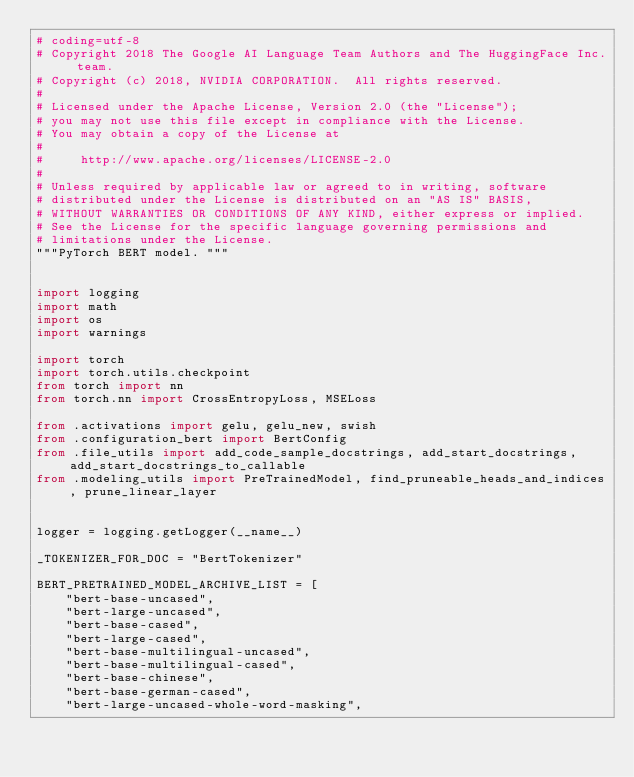<code> <loc_0><loc_0><loc_500><loc_500><_Python_># coding=utf-8
# Copyright 2018 The Google AI Language Team Authors and The HuggingFace Inc. team.
# Copyright (c) 2018, NVIDIA CORPORATION.  All rights reserved.
#
# Licensed under the Apache License, Version 2.0 (the "License");
# you may not use this file except in compliance with the License.
# You may obtain a copy of the License at
#
#     http://www.apache.org/licenses/LICENSE-2.0
#
# Unless required by applicable law or agreed to in writing, software
# distributed under the License is distributed on an "AS IS" BASIS,
# WITHOUT WARRANTIES OR CONDITIONS OF ANY KIND, either express or implied.
# See the License for the specific language governing permissions and
# limitations under the License.
"""PyTorch BERT model. """


import logging
import math
import os
import warnings

import torch
import torch.utils.checkpoint
from torch import nn
from torch.nn import CrossEntropyLoss, MSELoss

from .activations import gelu, gelu_new, swish
from .configuration_bert import BertConfig
from .file_utils import add_code_sample_docstrings, add_start_docstrings, add_start_docstrings_to_callable
from .modeling_utils import PreTrainedModel, find_pruneable_heads_and_indices, prune_linear_layer


logger = logging.getLogger(__name__)

_TOKENIZER_FOR_DOC = "BertTokenizer"

BERT_PRETRAINED_MODEL_ARCHIVE_LIST = [
    "bert-base-uncased",
    "bert-large-uncased",
    "bert-base-cased",
    "bert-large-cased",
    "bert-base-multilingual-uncased",
    "bert-base-multilingual-cased",
    "bert-base-chinese",
    "bert-base-german-cased",
    "bert-large-uncased-whole-word-masking",</code> 